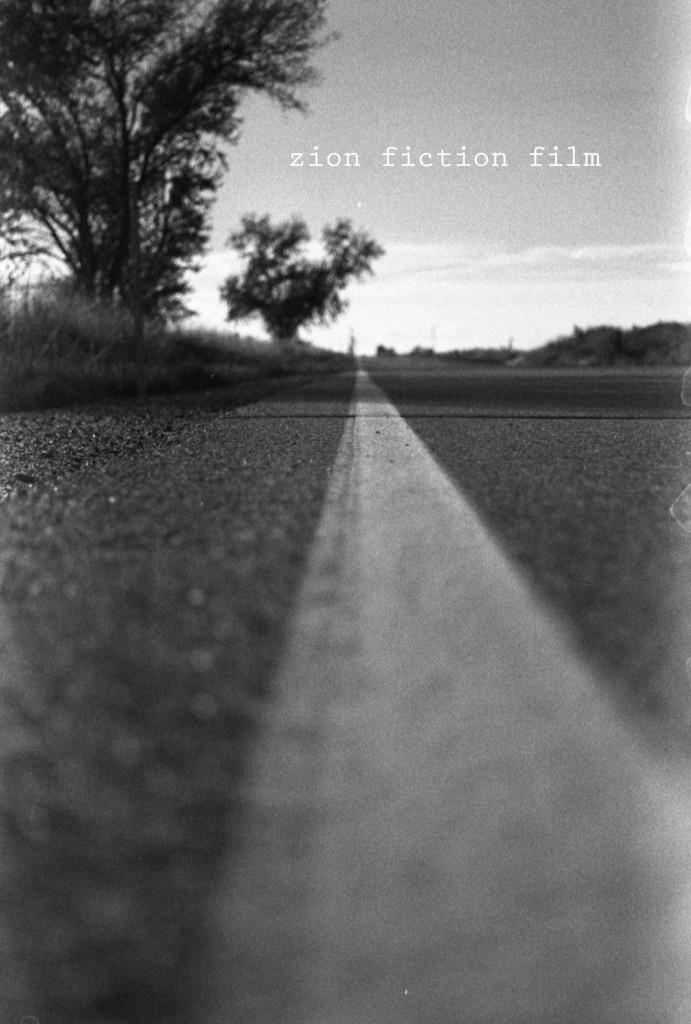What is the color scheme of the image? The image is black and white. What can be seen in the image besides the color scheme? There is a road in the image. What type of vegetation is on the left side of the image? There are trees on the left side of the image. What is visible at the top of the image? The sky is visible at the top of the image. Can you see an owl perched on the trees in the image? There is no owl present in the image; only trees are visible on the left side. Is there a slip visible on the road in the image? There is no slip visible on the road in the image; only the road itself is visible. 